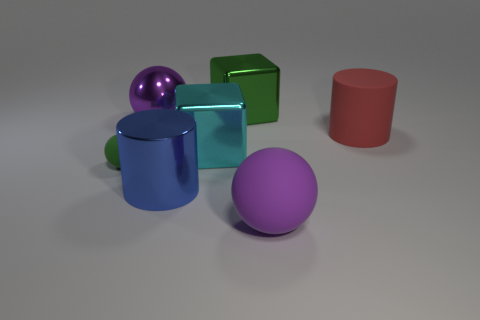There is a sphere right of the large blue thing; are there any big spheres that are behind it?
Offer a very short reply. Yes. There is a big sphere that is behind the large metallic cube that is in front of the big red cylinder; what number of small objects are to the right of it?
Offer a terse response. 0. There is a shiny thing that is right of the purple shiny object and behind the red thing; what color is it?
Provide a succinct answer. Green. How many blocks are the same color as the shiny sphere?
Offer a very short reply. 0. What number of cubes are tiny green objects or big green things?
Keep it short and to the point. 1. What color is the metal cylinder that is the same size as the metallic ball?
Your response must be concise. Blue. There is a large metal block in front of the cylinder behind the tiny green matte ball; is there a matte thing that is behind it?
Your answer should be compact. Yes. The blue shiny thing has what size?
Provide a succinct answer. Large. What number of things are either green spheres or big brown blocks?
Your answer should be compact. 1. There is a large ball that is made of the same material as the big blue cylinder; what is its color?
Your answer should be very brief. Purple. 